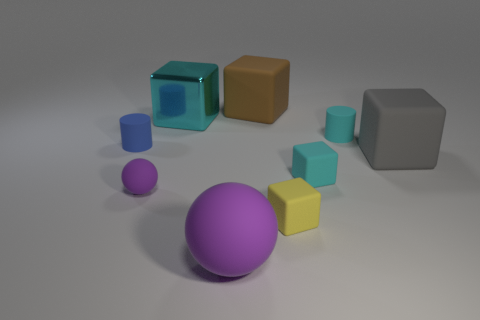What is the material of the small cylinder that is behind the tiny cylinder that is on the left side of the big shiny object?
Your answer should be compact. Rubber. What number of metallic objects are either big balls or big red cubes?
Provide a short and direct response. 0. Are there any other things that have the same material as the large cyan object?
Provide a succinct answer. No. Is there a purple sphere behind the purple ball right of the large cyan thing?
Your answer should be very brief. Yes. What number of objects are matte objects that are in front of the metallic object or large blocks to the right of the large purple ball?
Keep it short and to the point. 8. Is there any other thing of the same color as the big metallic object?
Provide a succinct answer. Yes. The large cube on the left side of the large rubber thing that is behind the rubber cylinder on the right side of the brown rubber cube is what color?
Ensure brevity in your answer.  Cyan. There is a cyan matte object to the left of the cylinder that is to the right of the large cyan cube; what is its size?
Your answer should be compact. Small. The cyan object that is on the left side of the small cyan rubber cylinder and behind the big gray matte object is made of what material?
Your answer should be compact. Metal. Do the cyan metallic object and the matte block behind the large gray rubber object have the same size?
Provide a succinct answer. Yes. 